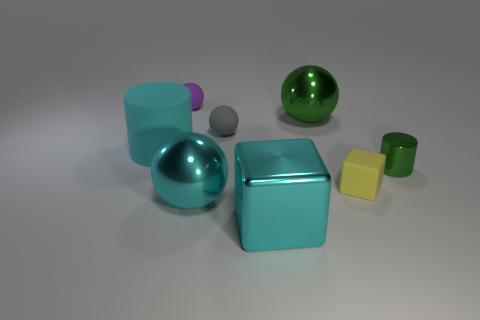Subtract 1 spheres. How many spheres are left? 3 Add 2 big cyan rubber balls. How many objects exist? 10 Subtract all cylinders. How many objects are left? 6 Add 2 cyan shiny balls. How many cyan shiny balls exist? 3 Subtract 1 gray spheres. How many objects are left? 7 Subtract all matte spheres. Subtract all tiny yellow objects. How many objects are left? 5 Add 8 cyan rubber things. How many cyan rubber things are left? 9 